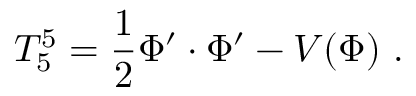<formula> <loc_0><loc_0><loc_500><loc_500>T _ { 5 } ^ { 5 } = { \frac { 1 } { 2 } } \Phi ^ { \prime } \cdot \Phi ^ { \prime } - V ( \Phi ) .</formula> 